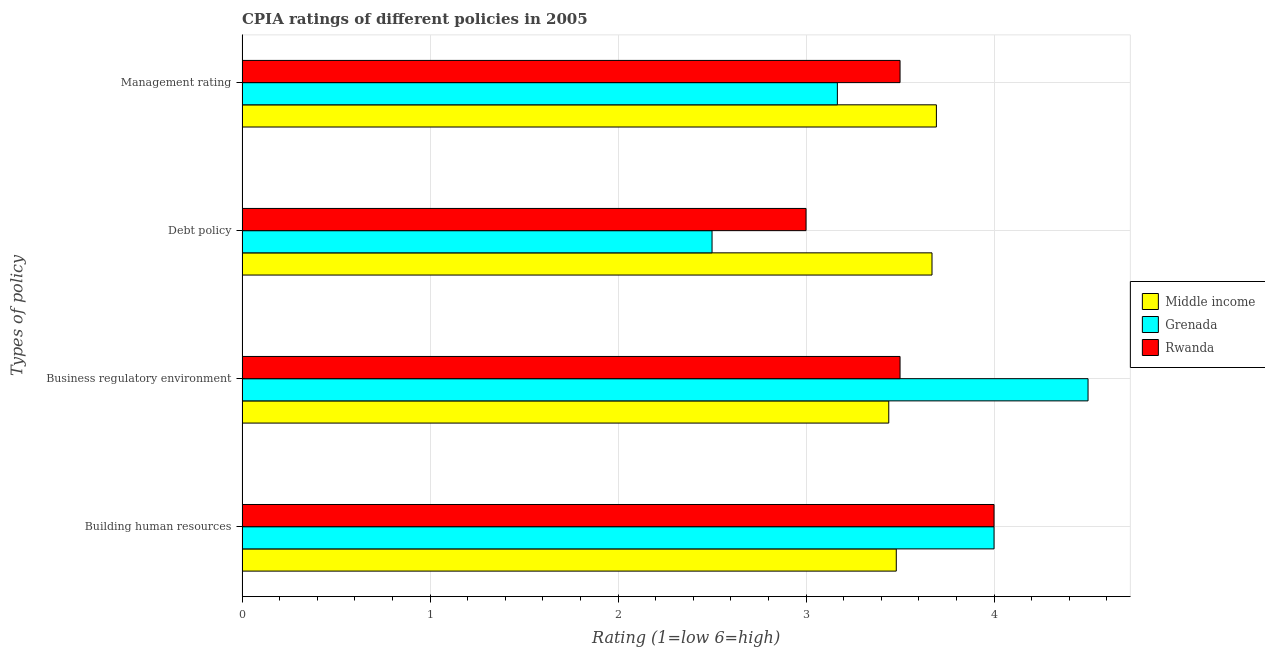How many bars are there on the 1st tick from the top?
Provide a succinct answer. 3. What is the label of the 2nd group of bars from the top?
Provide a short and direct response. Debt policy. What is the cpia rating of business regulatory environment in Middle income?
Offer a terse response. 3.44. Across all countries, what is the maximum cpia rating of management?
Your answer should be very brief. 3.69. Across all countries, what is the minimum cpia rating of building human resources?
Make the answer very short. 3.48. In which country was the cpia rating of business regulatory environment maximum?
Ensure brevity in your answer.  Grenada. In which country was the cpia rating of management minimum?
Offer a very short reply. Grenada. What is the total cpia rating of business regulatory environment in the graph?
Provide a succinct answer. 11.44. What is the difference between the cpia rating of debt policy in Middle income and that in Grenada?
Provide a short and direct response. 1.17. What is the difference between the cpia rating of building human resources in Middle income and the cpia rating of business regulatory environment in Grenada?
Your response must be concise. -1.02. What is the average cpia rating of management per country?
Provide a succinct answer. 3.45. What is the difference between the cpia rating of management and cpia rating of business regulatory environment in Middle income?
Provide a short and direct response. 0.25. What is the ratio of the cpia rating of building human resources in Rwanda to that in Middle income?
Provide a succinct answer. 1.15. Is the difference between the cpia rating of business regulatory environment in Grenada and Middle income greater than the difference between the cpia rating of debt policy in Grenada and Middle income?
Make the answer very short. Yes. What is the difference between the highest and the second highest cpia rating of building human resources?
Ensure brevity in your answer.  0. What is the difference between the highest and the lowest cpia rating of building human resources?
Your answer should be compact. 0.52. In how many countries, is the cpia rating of business regulatory environment greater than the average cpia rating of business regulatory environment taken over all countries?
Give a very brief answer. 1. Is the sum of the cpia rating of management in Rwanda and Middle income greater than the maximum cpia rating of business regulatory environment across all countries?
Keep it short and to the point. Yes. What does the 3rd bar from the top in Management rating represents?
Offer a very short reply. Middle income. What does the 2nd bar from the bottom in Debt policy represents?
Give a very brief answer. Grenada. What is the difference between two consecutive major ticks on the X-axis?
Keep it short and to the point. 1. Are the values on the major ticks of X-axis written in scientific E-notation?
Your answer should be very brief. No. What is the title of the graph?
Offer a very short reply. CPIA ratings of different policies in 2005. What is the label or title of the X-axis?
Your response must be concise. Rating (1=low 6=high). What is the label or title of the Y-axis?
Make the answer very short. Types of policy. What is the Rating (1=low 6=high) in Middle income in Building human resources?
Offer a very short reply. 3.48. What is the Rating (1=low 6=high) in Rwanda in Building human resources?
Give a very brief answer. 4. What is the Rating (1=low 6=high) of Middle income in Business regulatory environment?
Your response must be concise. 3.44. What is the Rating (1=low 6=high) in Middle income in Debt policy?
Keep it short and to the point. 3.67. What is the Rating (1=low 6=high) of Grenada in Debt policy?
Provide a short and direct response. 2.5. What is the Rating (1=low 6=high) in Rwanda in Debt policy?
Your response must be concise. 3. What is the Rating (1=low 6=high) of Middle income in Management rating?
Provide a short and direct response. 3.69. What is the Rating (1=low 6=high) of Grenada in Management rating?
Offer a terse response. 3.17. Across all Types of policy, what is the maximum Rating (1=low 6=high) of Middle income?
Your answer should be compact. 3.69. Across all Types of policy, what is the maximum Rating (1=low 6=high) of Rwanda?
Offer a terse response. 4. Across all Types of policy, what is the minimum Rating (1=low 6=high) in Middle income?
Your answer should be very brief. 3.44. Across all Types of policy, what is the minimum Rating (1=low 6=high) of Rwanda?
Offer a very short reply. 3. What is the total Rating (1=low 6=high) of Middle income in the graph?
Make the answer very short. 14.28. What is the total Rating (1=low 6=high) of Grenada in the graph?
Ensure brevity in your answer.  14.17. What is the total Rating (1=low 6=high) in Rwanda in the graph?
Make the answer very short. 14. What is the difference between the Rating (1=low 6=high) of Middle income in Building human resources and that in Business regulatory environment?
Your answer should be very brief. 0.04. What is the difference between the Rating (1=low 6=high) of Middle income in Building human resources and that in Debt policy?
Offer a very short reply. -0.19. What is the difference between the Rating (1=low 6=high) in Rwanda in Building human resources and that in Debt policy?
Make the answer very short. 1. What is the difference between the Rating (1=low 6=high) of Middle income in Building human resources and that in Management rating?
Keep it short and to the point. -0.21. What is the difference between the Rating (1=low 6=high) in Middle income in Business regulatory environment and that in Debt policy?
Give a very brief answer. -0.23. What is the difference between the Rating (1=low 6=high) of Middle income in Business regulatory environment and that in Management rating?
Make the answer very short. -0.25. What is the difference between the Rating (1=low 6=high) of Grenada in Business regulatory environment and that in Management rating?
Provide a short and direct response. 1.33. What is the difference between the Rating (1=low 6=high) of Middle income in Debt policy and that in Management rating?
Give a very brief answer. -0.02. What is the difference between the Rating (1=low 6=high) in Grenada in Debt policy and that in Management rating?
Make the answer very short. -0.67. What is the difference between the Rating (1=low 6=high) of Rwanda in Debt policy and that in Management rating?
Make the answer very short. -0.5. What is the difference between the Rating (1=low 6=high) in Middle income in Building human resources and the Rating (1=low 6=high) in Grenada in Business regulatory environment?
Ensure brevity in your answer.  -1.02. What is the difference between the Rating (1=low 6=high) of Middle income in Building human resources and the Rating (1=low 6=high) of Rwanda in Business regulatory environment?
Offer a very short reply. -0.02. What is the difference between the Rating (1=low 6=high) of Grenada in Building human resources and the Rating (1=low 6=high) of Rwanda in Business regulatory environment?
Keep it short and to the point. 0.5. What is the difference between the Rating (1=low 6=high) of Middle income in Building human resources and the Rating (1=low 6=high) of Grenada in Debt policy?
Provide a succinct answer. 0.98. What is the difference between the Rating (1=low 6=high) of Middle income in Building human resources and the Rating (1=low 6=high) of Rwanda in Debt policy?
Your answer should be compact. 0.48. What is the difference between the Rating (1=low 6=high) of Grenada in Building human resources and the Rating (1=low 6=high) of Rwanda in Debt policy?
Provide a succinct answer. 1. What is the difference between the Rating (1=low 6=high) in Middle income in Building human resources and the Rating (1=low 6=high) in Grenada in Management rating?
Your answer should be compact. 0.31. What is the difference between the Rating (1=low 6=high) in Middle income in Building human resources and the Rating (1=low 6=high) in Rwanda in Management rating?
Provide a succinct answer. -0.02. What is the difference between the Rating (1=low 6=high) of Middle income in Business regulatory environment and the Rating (1=low 6=high) of Rwanda in Debt policy?
Your response must be concise. 0.44. What is the difference between the Rating (1=low 6=high) in Grenada in Business regulatory environment and the Rating (1=low 6=high) in Rwanda in Debt policy?
Keep it short and to the point. 1.5. What is the difference between the Rating (1=low 6=high) of Middle income in Business regulatory environment and the Rating (1=low 6=high) of Grenada in Management rating?
Provide a succinct answer. 0.27. What is the difference between the Rating (1=low 6=high) in Middle income in Business regulatory environment and the Rating (1=low 6=high) in Rwanda in Management rating?
Offer a terse response. -0.06. What is the difference between the Rating (1=low 6=high) in Middle income in Debt policy and the Rating (1=low 6=high) in Grenada in Management rating?
Offer a very short reply. 0.5. What is the difference between the Rating (1=low 6=high) in Middle income in Debt policy and the Rating (1=low 6=high) in Rwanda in Management rating?
Make the answer very short. 0.17. What is the average Rating (1=low 6=high) of Middle income per Types of policy?
Give a very brief answer. 3.57. What is the average Rating (1=low 6=high) in Grenada per Types of policy?
Your answer should be compact. 3.54. What is the average Rating (1=low 6=high) in Rwanda per Types of policy?
Provide a succinct answer. 3.5. What is the difference between the Rating (1=low 6=high) of Middle income and Rating (1=low 6=high) of Grenada in Building human resources?
Offer a terse response. -0.52. What is the difference between the Rating (1=low 6=high) of Middle income and Rating (1=low 6=high) of Rwanda in Building human resources?
Offer a very short reply. -0.52. What is the difference between the Rating (1=low 6=high) of Grenada and Rating (1=low 6=high) of Rwanda in Building human resources?
Provide a short and direct response. 0. What is the difference between the Rating (1=low 6=high) in Middle income and Rating (1=low 6=high) in Grenada in Business regulatory environment?
Ensure brevity in your answer.  -1.06. What is the difference between the Rating (1=low 6=high) of Middle income and Rating (1=low 6=high) of Rwanda in Business regulatory environment?
Make the answer very short. -0.06. What is the difference between the Rating (1=low 6=high) in Middle income and Rating (1=low 6=high) in Grenada in Debt policy?
Offer a very short reply. 1.17. What is the difference between the Rating (1=low 6=high) of Middle income and Rating (1=low 6=high) of Rwanda in Debt policy?
Provide a short and direct response. 0.67. What is the difference between the Rating (1=low 6=high) of Grenada and Rating (1=low 6=high) of Rwanda in Debt policy?
Make the answer very short. -0.5. What is the difference between the Rating (1=low 6=high) of Middle income and Rating (1=low 6=high) of Grenada in Management rating?
Ensure brevity in your answer.  0.53. What is the difference between the Rating (1=low 6=high) of Middle income and Rating (1=low 6=high) of Rwanda in Management rating?
Keep it short and to the point. 0.19. What is the ratio of the Rating (1=low 6=high) in Middle income in Building human resources to that in Business regulatory environment?
Offer a terse response. 1.01. What is the ratio of the Rating (1=low 6=high) of Rwanda in Building human resources to that in Business regulatory environment?
Your answer should be compact. 1.14. What is the ratio of the Rating (1=low 6=high) of Middle income in Building human resources to that in Debt policy?
Your answer should be compact. 0.95. What is the ratio of the Rating (1=low 6=high) of Middle income in Building human resources to that in Management rating?
Give a very brief answer. 0.94. What is the ratio of the Rating (1=low 6=high) of Grenada in Building human resources to that in Management rating?
Your response must be concise. 1.26. What is the ratio of the Rating (1=low 6=high) of Middle income in Business regulatory environment to that in Debt policy?
Your answer should be compact. 0.94. What is the ratio of the Rating (1=low 6=high) of Rwanda in Business regulatory environment to that in Debt policy?
Provide a short and direct response. 1.17. What is the ratio of the Rating (1=low 6=high) of Middle income in Business regulatory environment to that in Management rating?
Your answer should be compact. 0.93. What is the ratio of the Rating (1=low 6=high) of Grenada in Business regulatory environment to that in Management rating?
Your answer should be very brief. 1.42. What is the ratio of the Rating (1=low 6=high) of Middle income in Debt policy to that in Management rating?
Offer a terse response. 0.99. What is the ratio of the Rating (1=low 6=high) of Grenada in Debt policy to that in Management rating?
Provide a short and direct response. 0.79. What is the ratio of the Rating (1=low 6=high) in Rwanda in Debt policy to that in Management rating?
Provide a short and direct response. 0.86. What is the difference between the highest and the second highest Rating (1=low 6=high) of Middle income?
Make the answer very short. 0.02. What is the difference between the highest and the second highest Rating (1=low 6=high) in Rwanda?
Your answer should be very brief. 0.5. What is the difference between the highest and the lowest Rating (1=low 6=high) in Middle income?
Ensure brevity in your answer.  0.25. What is the difference between the highest and the lowest Rating (1=low 6=high) of Grenada?
Keep it short and to the point. 2. 